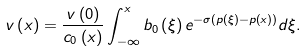<formula> <loc_0><loc_0><loc_500><loc_500>v \left ( x \right ) = \frac { v \left ( 0 \right ) } { c _ { 0 } \left ( x \right ) } \int _ { - \infty } ^ { x } b _ { 0 } \left ( \xi \right ) e ^ { - \sigma \left ( p \left ( \xi \right ) - p \left ( x \right ) \right ) } d \xi .</formula> 